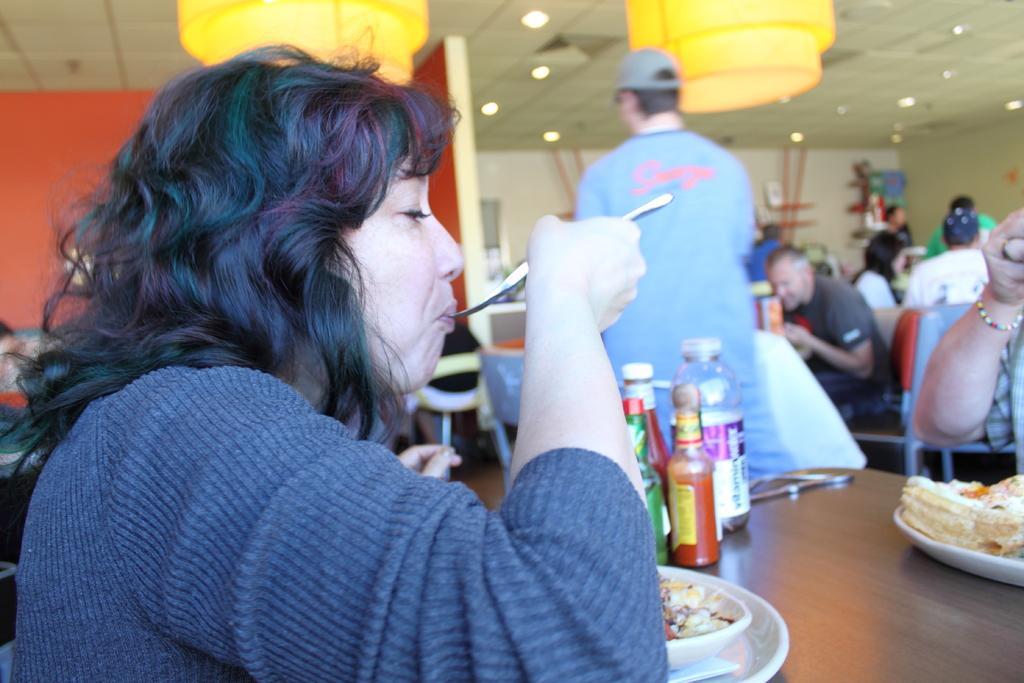Please provide a concise description of this image. In this picture I can see some people are sitting in front of the tables and eating, side I can see a person standing. 